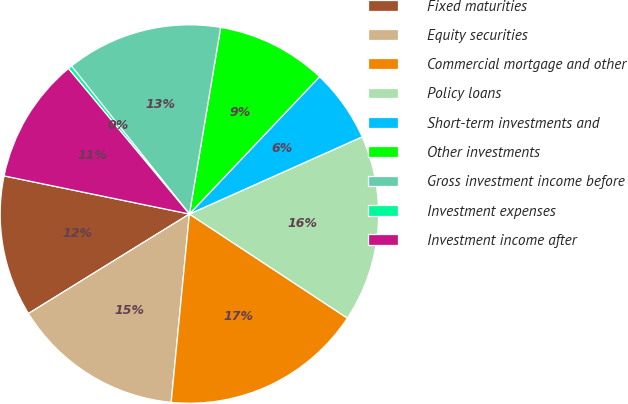Convert chart. <chart><loc_0><loc_0><loc_500><loc_500><pie_chart><fcel>Fixed maturities<fcel>Equity securities<fcel>Commercial mortgage and other<fcel>Policy loans<fcel>Short-term investments and<fcel>Other investments<fcel>Gross investment income before<fcel>Investment expenses<fcel>Investment income after<nl><fcel>12.04%<fcel>14.65%<fcel>17.26%<fcel>15.96%<fcel>6.24%<fcel>9.43%<fcel>13.35%<fcel>0.33%<fcel>10.73%<nl></chart> 